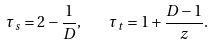Convert formula to latex. <formula><loc_0><loc_0><loc_500><loc_500>\tau _ { s } = 2 - \frac { 1 } { D } , \quad \tau _ { t } = 1 + \frac { D - 1 } { z } .</formula> 